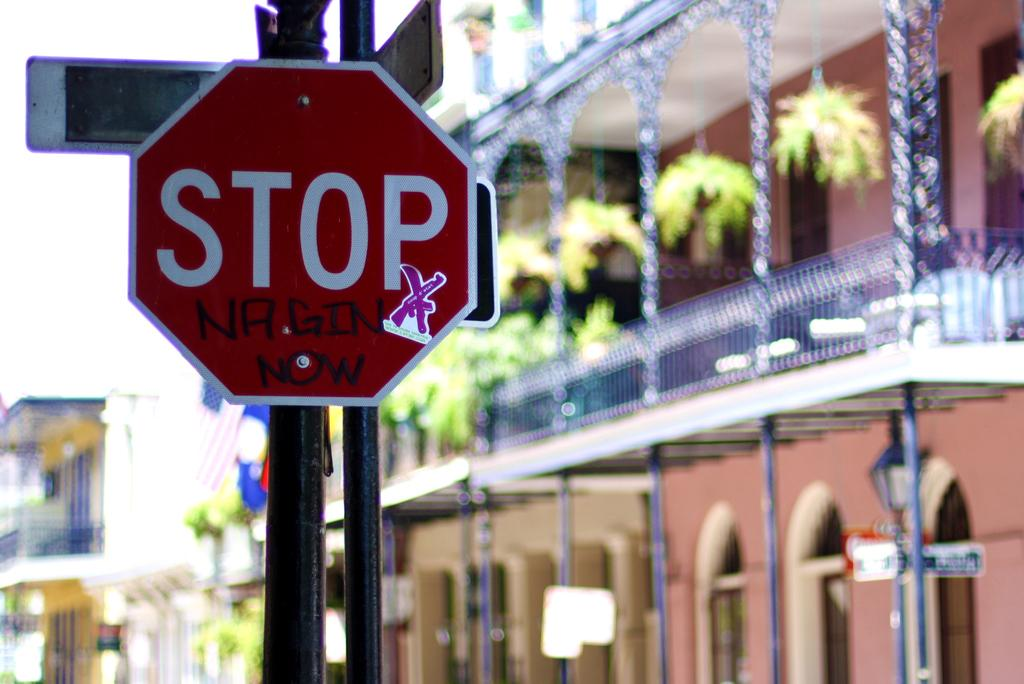<image>
Create a compact narrative representing the image presented. A stop sign with graffiti saying NRG GIN now and a purple ribbon sticker on it. 